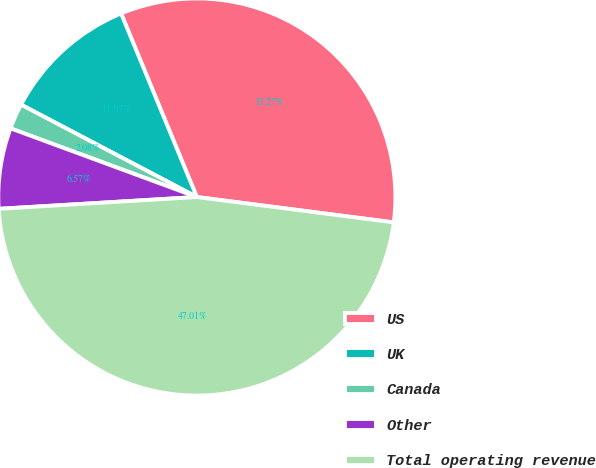<chart> <loc_0><loc_0><loc_500><loc_500><pie_chart><fcel>US<fcel>UK<fcel>Canada<fcel>Other<fcel>Total operating revenue<nl><fcel>33.27%<fcel>11.07%<fcel>2.08%<fcel>6.57%<fcel>47.01%<nl></chart> 